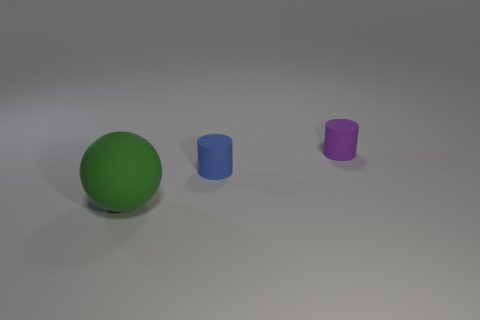There is a object that is both in front of the small purple rubber object and on the right side of the green matte sphere; what color is it?
Your response must be concise. Blue. Are there any large green things of the same shape as the tiny blue object?
Offer a very short reply. No. There is a matte cylinder on the left side of the small purple matte cylinder; is there a small object right of it?
Your answer should be very brief. Yes. What number of objects are either cylinders that are in front of the tiny purple matte object or matte things that are behind the ball?
Offer a very short reply. 2. What number of things are yellow blocks or rubber cylinders that are left of the tiny purple cylinder?
Ensure brevity in your answer.  1. What is the size of the rubber thing that is behind the tiny matte object that is in front of the matte cylinder to the right of the blue matte thing?
Keep it short and to the point. Small. There is a object that is the same size as the blue rubber cylinder; what material is it?
Give a very brief answer. Rubber. Are there any rubber balls that have the same size as the green thing?
Make the answer very short. No. Does the cylinder on the left side of the purple rubber cylinder have the same size as the large green matte sphere?
Make the answer very short. No. There is a rubber thing that is in front of the purple matte cylinder and to the right of the green object; what shape is it?
Your response must be concise. Cylinder. 